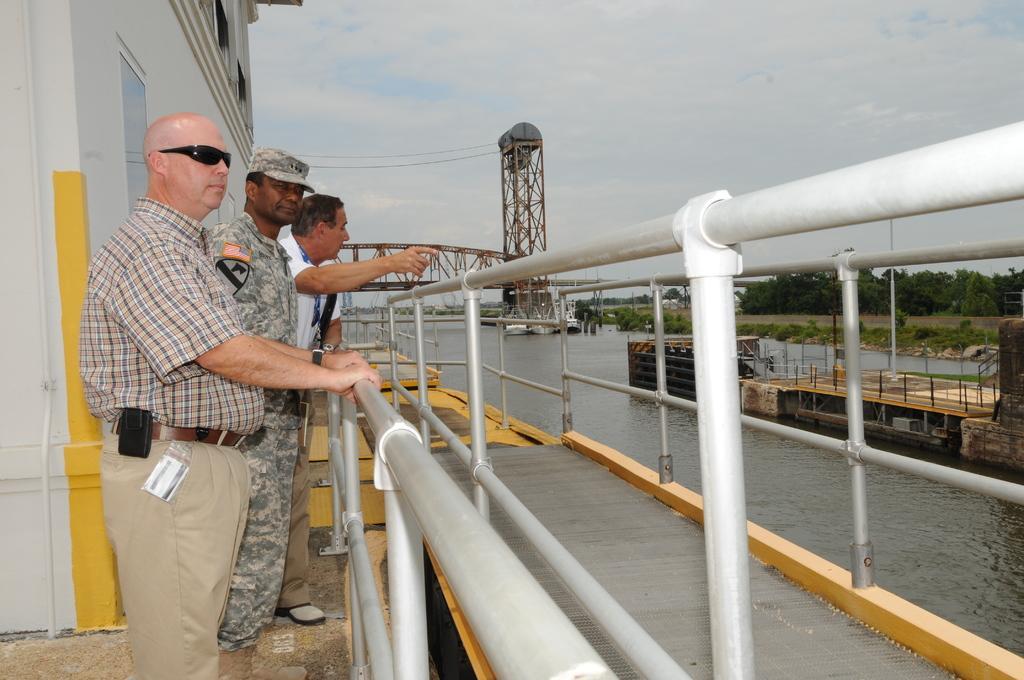In one or two sentences, can you explain what this image depicts? In this picture, we see three men are standing. In front of them, we see the railings. Behind them, we see a wall in white color. They might be standing in the ship. Here, we see water and this water might be in the lake. On the right side, we see an object which looks like a boat. Behind that, there are trees. In the background, we see an arch bridge. At the top of the picture, we see the sky. 